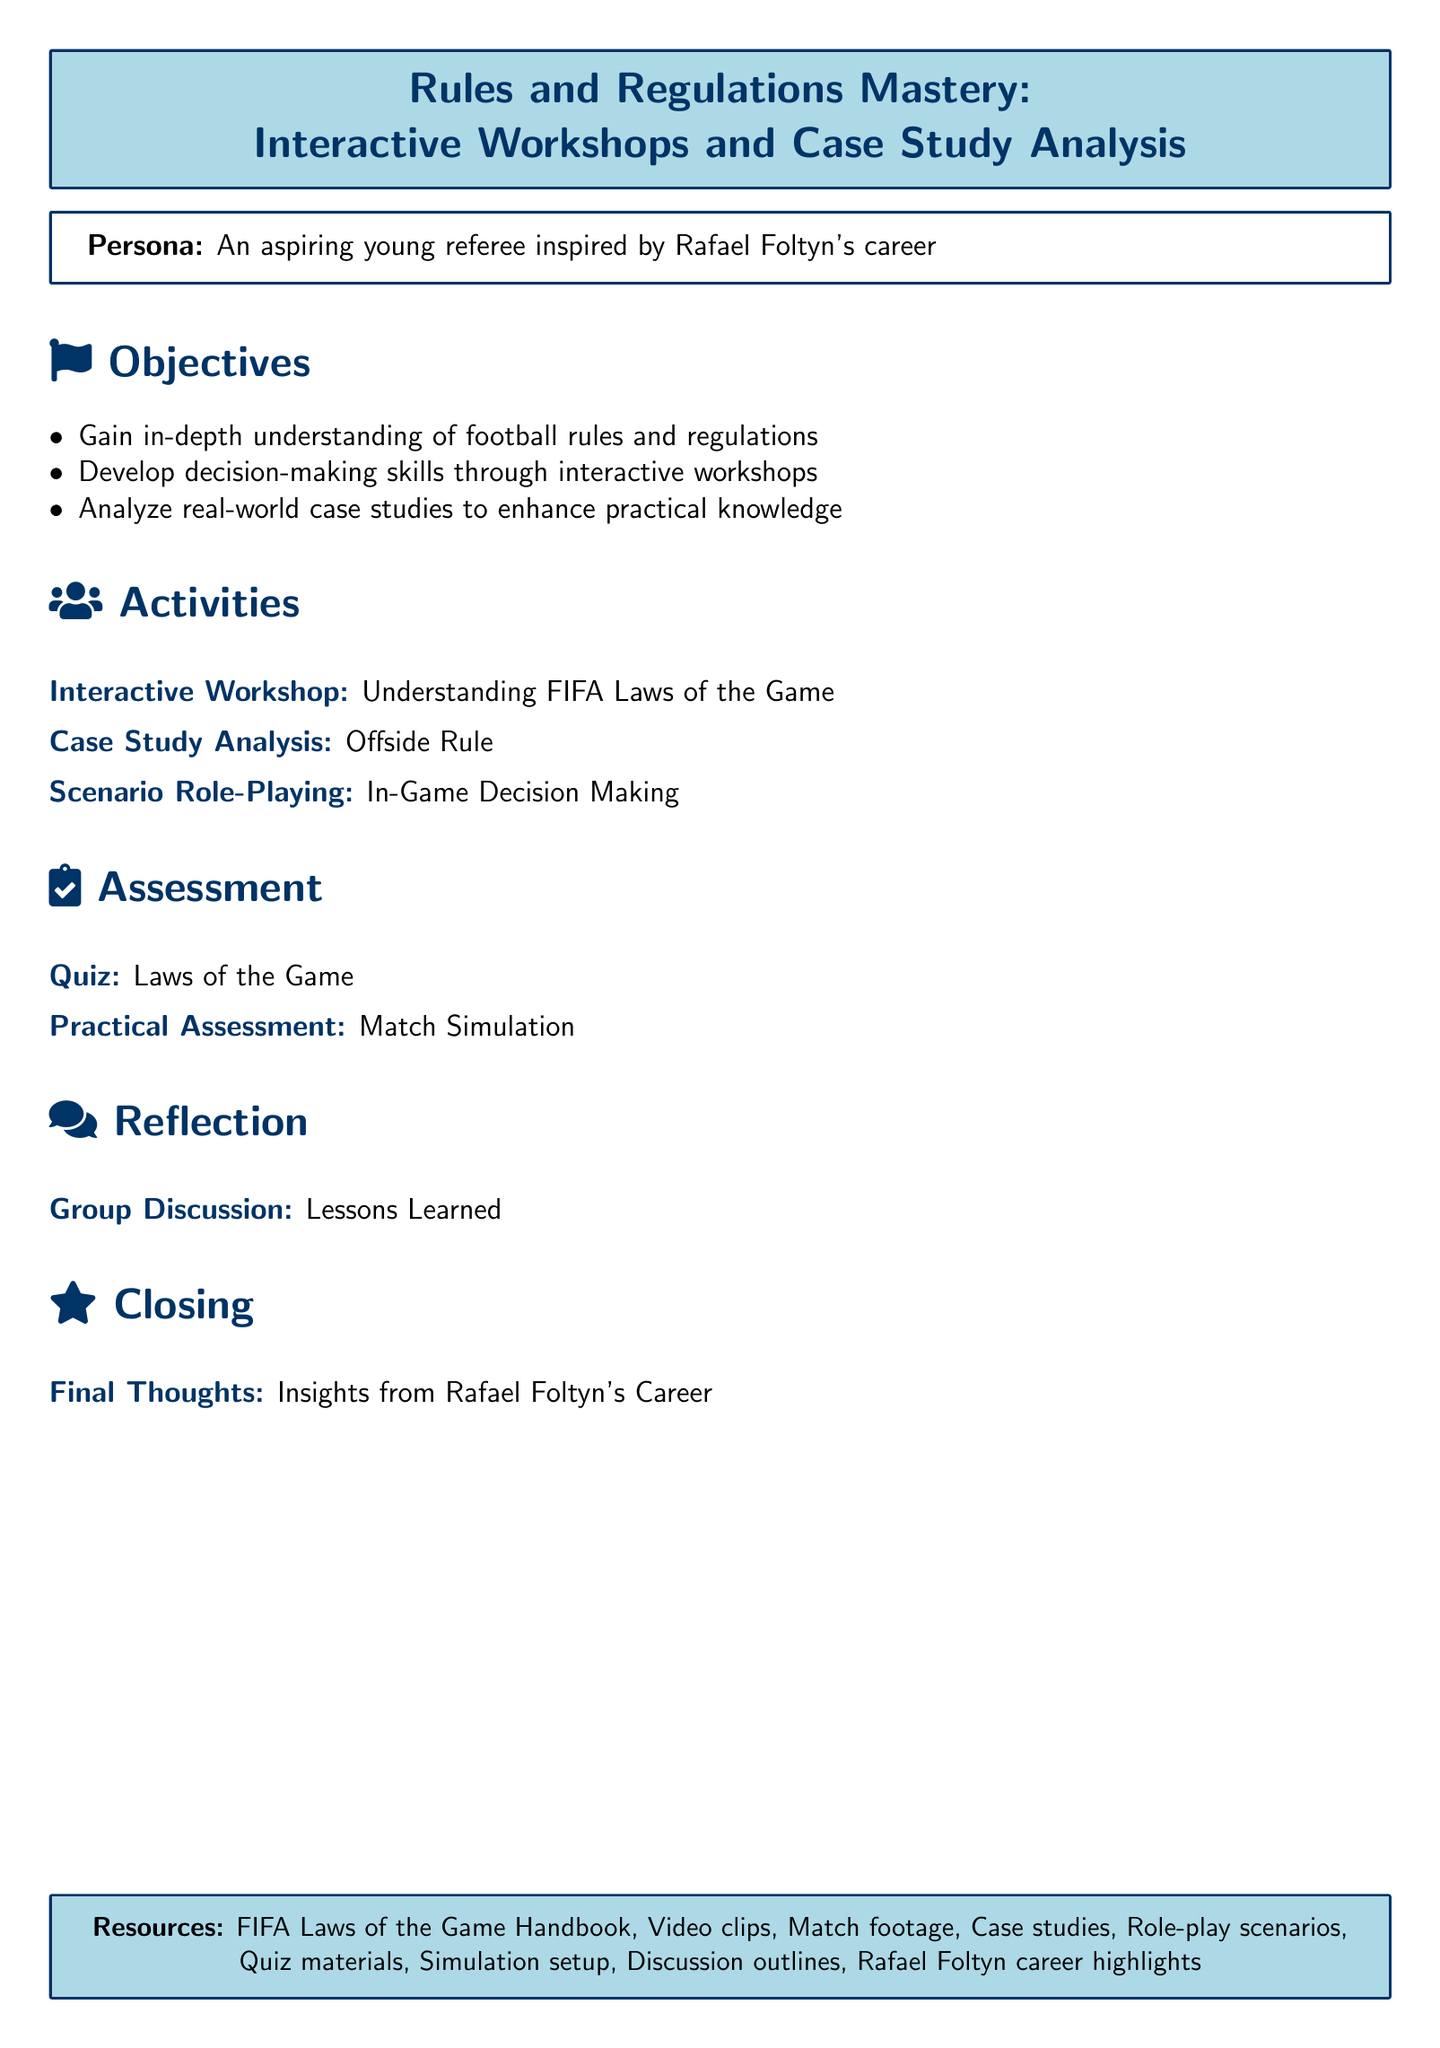What is the document type? The document is a lesson plan designed for an aspiring young referee.
Answer: Lesson plan Who is the persona described in the document? The persona mentioned is an aspiring young referee inspired by Rafael Foltyn.
Answer: Aspiring young referee What is one of the objectives listed? The objectives include gaining an in-depth understanding of football rules and regulations.
Answer: Gain in-depth understanding of football rules and regulations What activity involves role-playing? The scenario role-playing activity focuses on in-game decision making.
Answer: In-Game Decision Making What is the total number of assessment activities mentioned? There are two assessment activities listed: a quiz and a practical assessment.
Answer: 2 What is the closing activity titled? The closing activity focuses on insights from Rafael Foltyn's career.
Answer: Insights from Rafael Foltyn's Career What is one type of resource included? One of the resources listed is the FIFA Laws of the Game Handbook.
Answer: FIFA Laws of the Game Handbook Which rule is analyzed in the case study activity? The case study analysis focuses specifically on the offside rule.
Answer: Offside Rule 